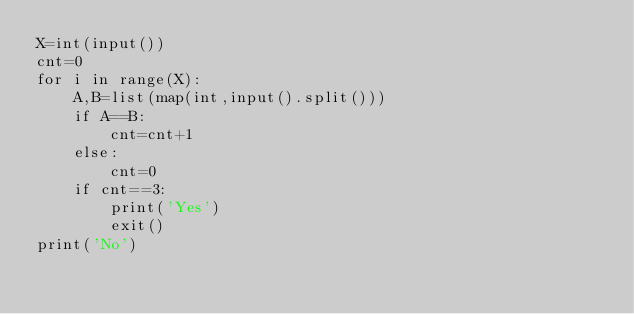<code> <loc_0><loc_0><loc_500><loc_500><_Python_>X=int(input())
cnt=0
for i in range(X):
    A,B=list(map(int,input().split()))
    if A==B:
        cnt=cnt+1
    else:
        cnt=0
    if cnt==3:
        print('Yes')
        exit()
print('No')</code> 